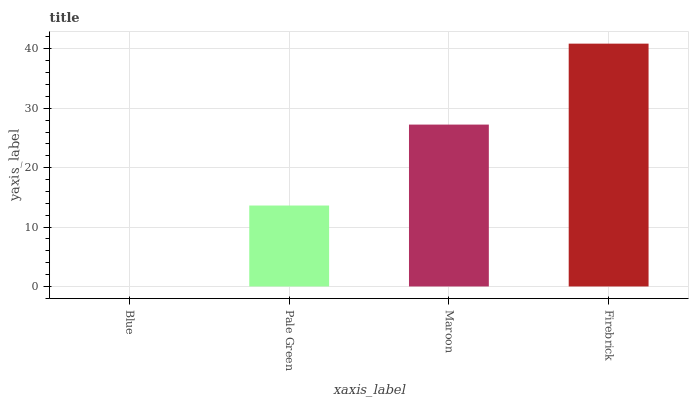Is Blue the minimum?
Answer yes or no. Yes. Is Firebrick the maximum?
Answer yes or no. Yes. Is Pale Green the minimum?
Answer yes or no. No. Is Pale Green the maximum?
Answer yes or no. No. Is Pale Green greater than Blue?
Answer yes or no. Yes. Is Blue less than Pale Green?
Answer yes or no. Yes. Is Blue greater than Pale Green?
Answer yes or no. No. Is Pale Green less than Blue?
Answer yes or no. No. Is Maroon the high median?
Answer yes or no. Yes. Is Pale Green the low median?
Answer yes or no. Yes. Is Blue the high median?
Answer yes or no. No. Is Firebrick the low median?
Answer yes or no. No. 